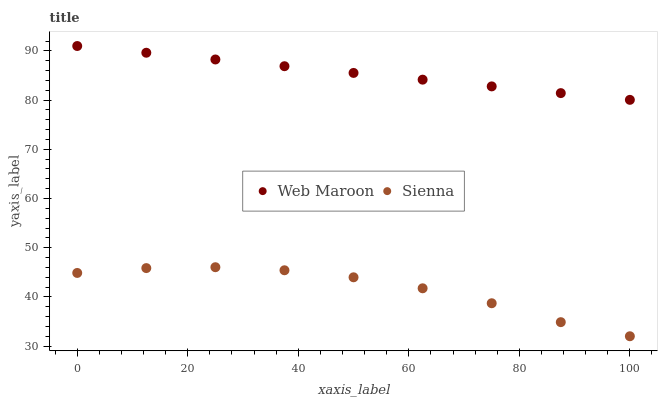Does Sienna have the minimum area under the curve?
Answer yes or no. Yes. Does Web Maroon have the maximum area under the curve?
Answer yes or no. Yes. Does Web Maroon have the minimum area under the curve?
Answer yes or no. No. Is Web Maroon the smoothest?
Answer yes or no. Yes. Is Sienna the roughest?
Answer yes or no. Yes. Is Web Maroon the roughest?
Answer yes or no. No. Does Sienna have the lowest value?
Answer yes or no. Yes. Does Web Maroon have the lowest value?
Answer yes or no. No. Does Web Maroon have the highest value?
Answer yes or no. Yes. Is Sienna less than Web Maroon?
Answer yes or no. Yes. Is Web Maroon greater than Sienna?
Answer yes or no. Yes. Does Sienna intersect Web Maroon?
Answer yes or no. No. 